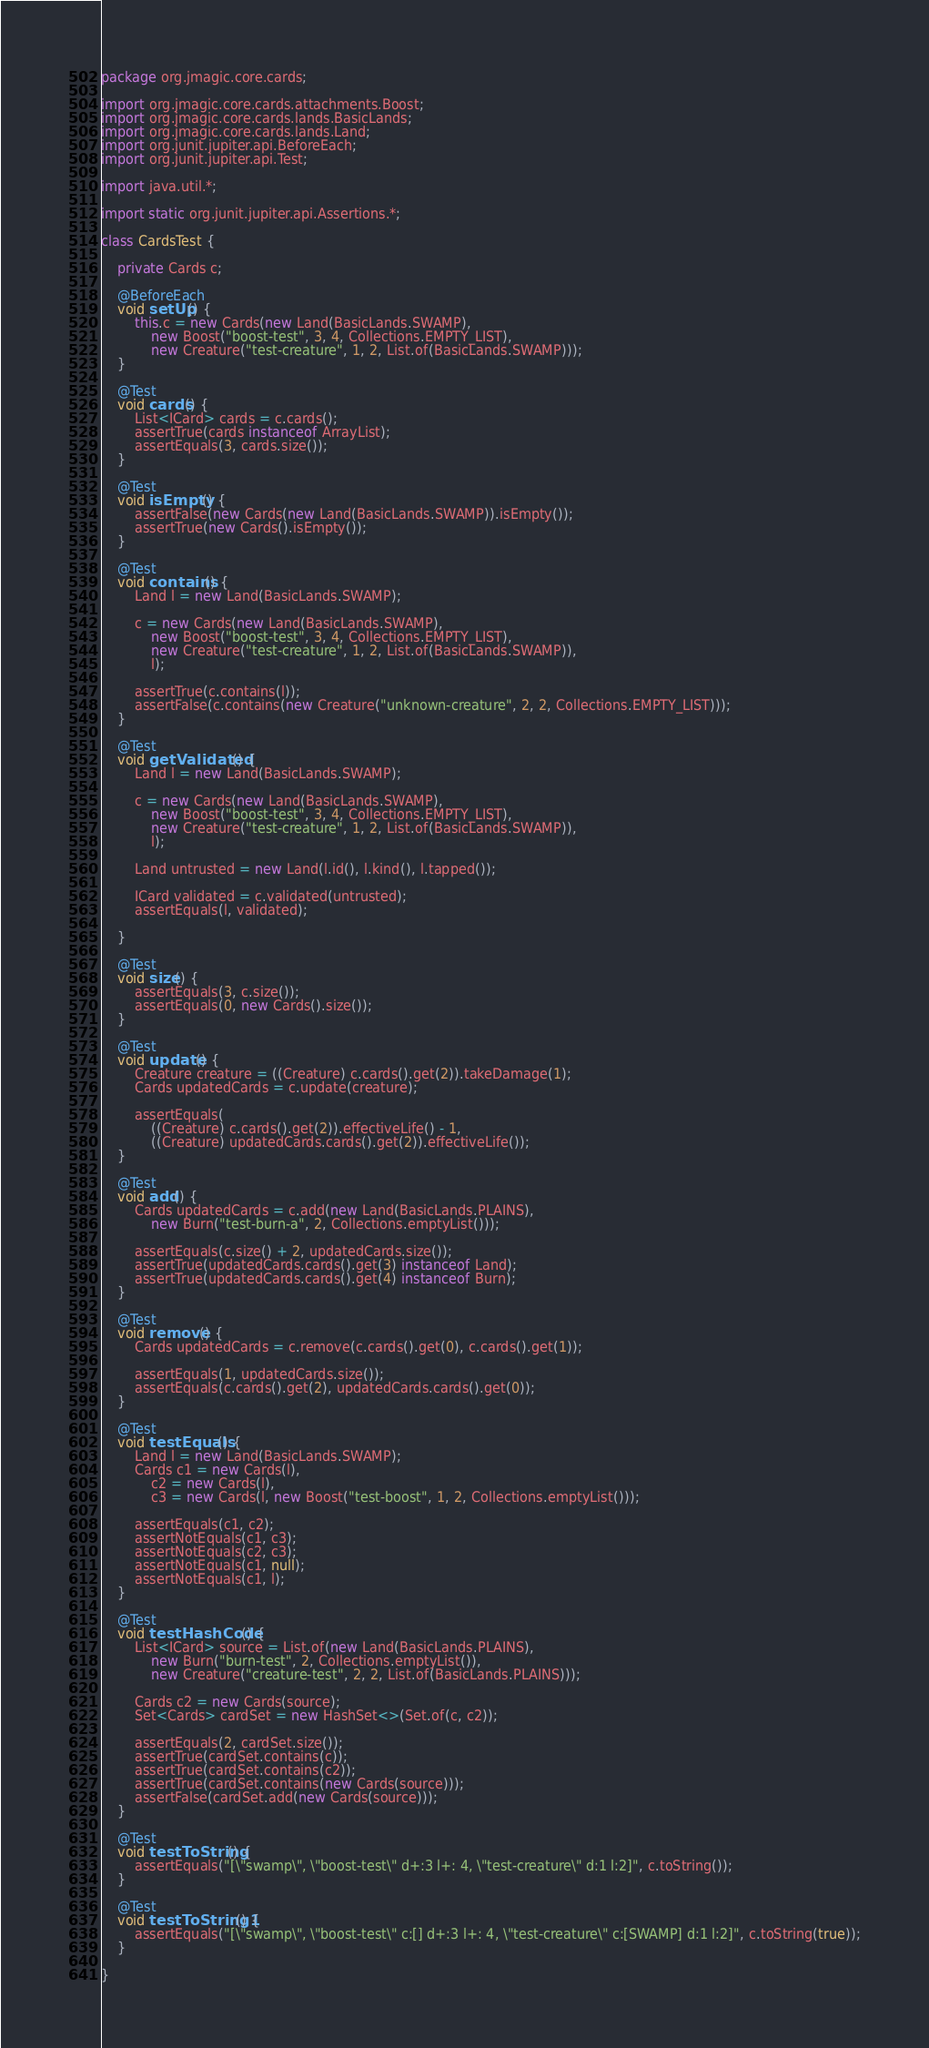<code> <loc_0><loc_0><loc_500><loc_500><_Java_>package org.jmagic.core.cards;

import org.jmagic.core.cards.attachments.Boost;
import org.jmagic.core.cards.lands.BasicLands;
import org.jmagic.core.cards.lands.Land;
import org.junit.jupiter.api.BeforeEach;
import org.junit.jupiter.api.Test;

import java.util.*;

import static org.junit.jupiter.api.Assertions.*;

class CardsTest {

    private Cards c;

    @BeforeEach
    void setUp() {
        this.c = new Cards(new Land(BasicLands.SWAMP),
            new Boost("boost-test", 3, 4, Collections.EMPTY_LIST),
            new Creature("test-creature", 1, 2, List.of(BasicLands.SWAMP)));
    }

    @Test
    void cards() {
        List<ICard> cards = c.cards();
        assertTrue(cards instanceof ArrayList);
        assertEquals(3, cards.size());
    }

    @Test
    void isEmpty() {
        assertFalse(new Cards(new Land(BasicLands.SWAMP)).isEmpty());
        assertTrue(new Cards().isEmpty());
    }

    @Test
    void contains() {
        Land l = new Land(BasicLands.SWAMP);

        c = new Cards(new Land(BasicLands.SWAMP),
            new Boost("boost-test", 3, 4, Collections.EMPTY_LIST),
            new Creature("test-creature", 1, 2, List.of(BasicLands.SWAMP)),
            l);

        assertTrue(c.contains(l));
        assertFalse(c.contains(new Creature("unknown-creature", 2, 2, Collections.EMPTY_LIST)));
    }

    @Test
    void getValidated() {
        Land l = new Land(BasicLands.SWAMP);

        c = new Cards(new Land(BasicLands.SWAMP),
            new Boost("boost-test", 3, 4, Collections.EMPTY_LIST),
            new Creature("test-creature", 1, 2, List.of(BasicLands.SWAMP)),
            l);

        Land untrusted = new Land(l.id(), l.kind(), l.tapped());

        ICard validated = c.validated(untrusted);
        assertEquals(l, validated);

    }

    @Test
    void size() {
        assertEquals(3, c.size());
        assertEquals(0, new Cards().size());
    }

    @Test
    void update() {
        Creature creature = ((Creature) c.cards().get(2)).takeDamage(1);
        Cards updatedCards = c.update(creature);

        assertEquals(
            ((Creature) c.cards().get(2)).effectiveLife() - 1,
            ((Creature) updatedCards.cards().get(2)).effectiveLife());
    }

    @Test
    void add() {
        Cards updatedCards = c.add(new Land(BasicLands.PLAINS),
            new Burn("test-burn-a", 2, Collections.emptyList()));

        assertEquals(c.size() + 2, updatedCards.size());
        assertTrue(updatedCards.cards().get(3) instanceof Land);
        assertTrue(updatedCards.cards().get(4) instanceof Burn);
    }

    @Test
    void remove() {
        Cards updatedCards = c.remove(c.cards().get(0), c.cards().get(1));

        assertEquals(1, updatedCards.size());
        assertEquals(c.cards().get(2), updatedCards.cards().get(0));
    }

    @Test
    void testEquals() {
        Land l = new Land(BasicLands.SWAMP);
        Cards c1 = new Cards(l),
            c2 = new Cards(l),
            c3 = new Cards(l, new Boost("test-boost", 1, 2, Collections.emptyList()));

        assertEquals(c1, c2);
        assertNotEquals(c1, c3);
        assertNotEquals(c2, c3);
        assertNotEquals(c1, null);
        assertNotEquals(c1, l);
    }

    @Test
    void testHashCode() {
        List<ICard> source = List.of(new Land(BasicLands.PLAINS),
            new Burn("burn-test", 2, Collections.emptyList()),
            new Creature("creature-test", 2, 2, List.of(BasicLands.PLAINS)));

        Cards c2 = new Cards(source);
        Set<Cards> cardSet = new HashSet<>(Set.of(c, c2));

        assertEquals(2, cardSet.size());
        assertTrue(cardSet.contains(c));
        assertTrue(cardSet.contains(c2));
        assertTrue(cardSet.contains(new Cards(source)));
        assertFalse(cardSet.add(new Cards(source)));
    }

    @Test
    void testToString() {
        assertEquals("[\"swamp\", \"boost-test\" d+:3 l+: 4, \"test-creature\" d:1 l:2]", c.toString());
    }

    @Test
    void testToString1() {
        assertEquals("[\"swamp\", \"boost-test\" c:[] d+:3 l+: 4, \"test-creature\" c:[SWAMP] d:1 l:2]", c.toString(true));
    }

}
</code> 